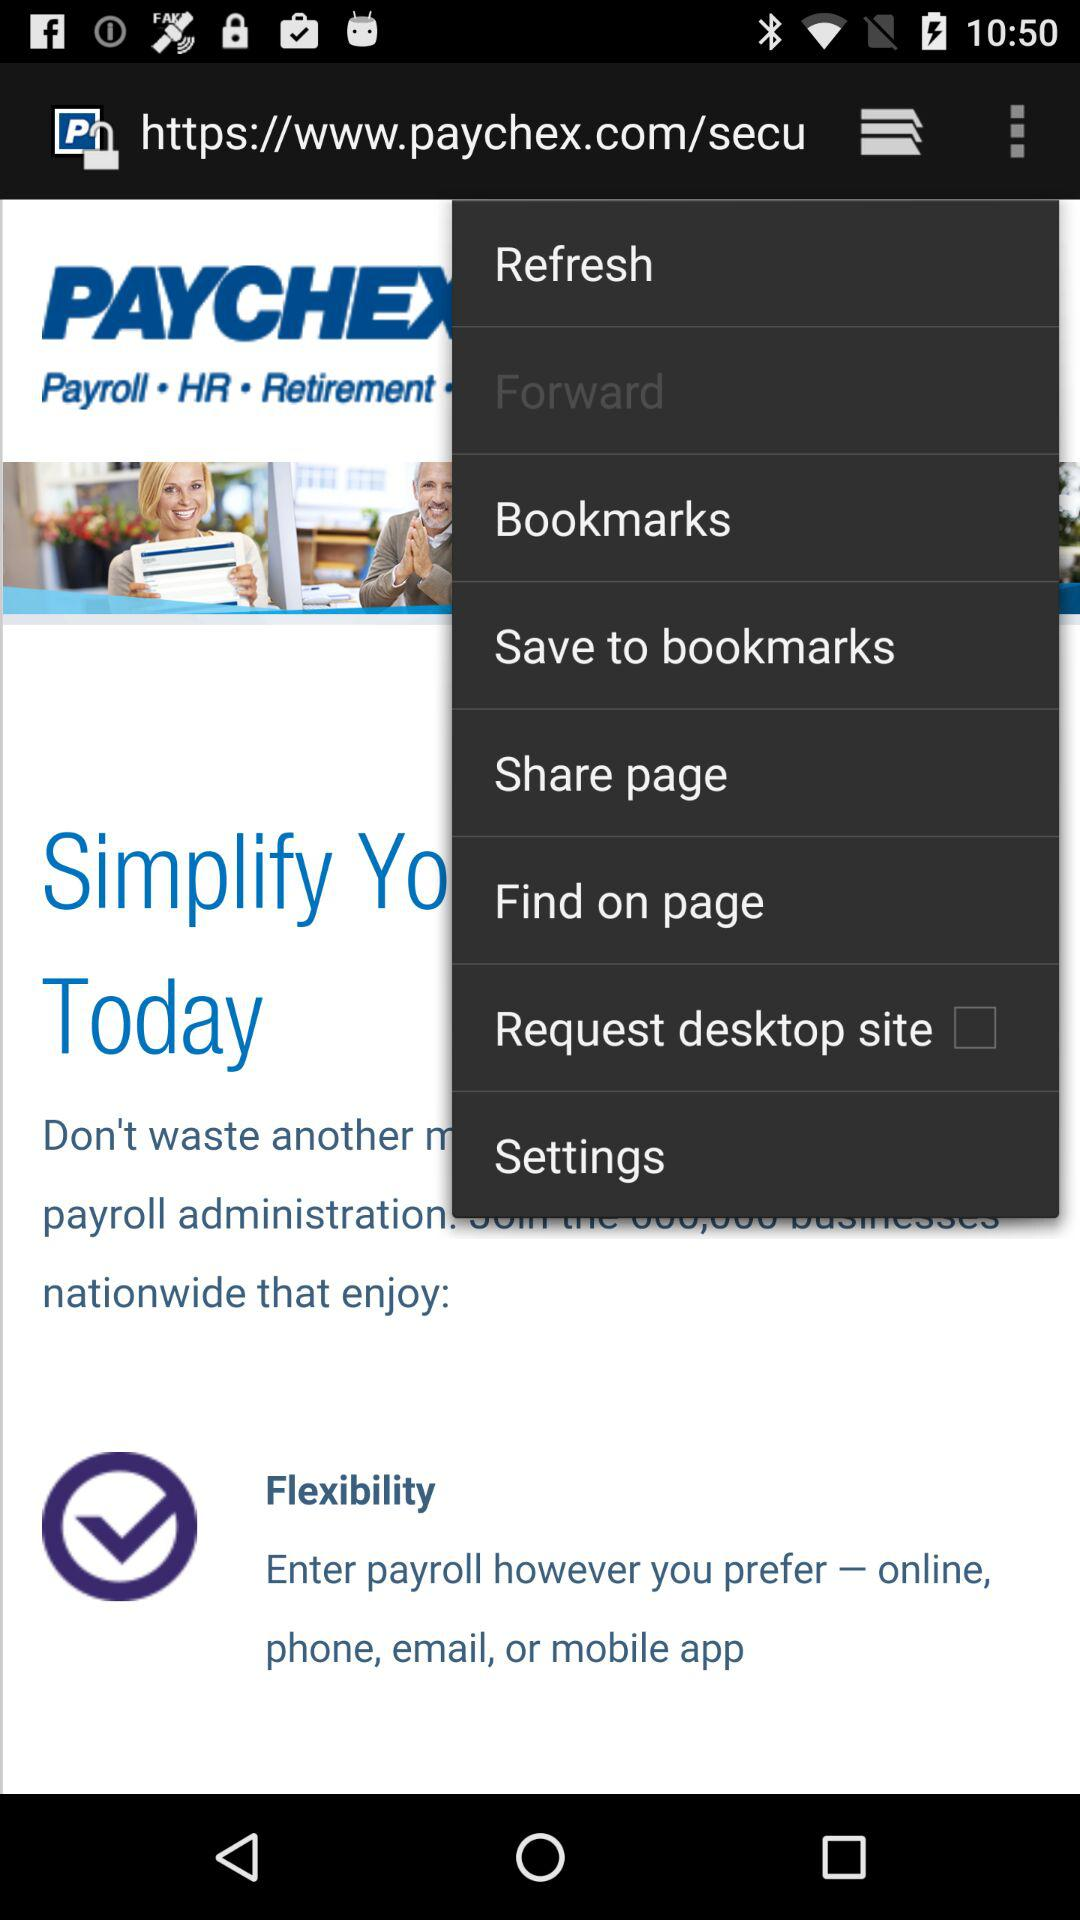What is the status of the "Request desktop site"? The status is "off". 